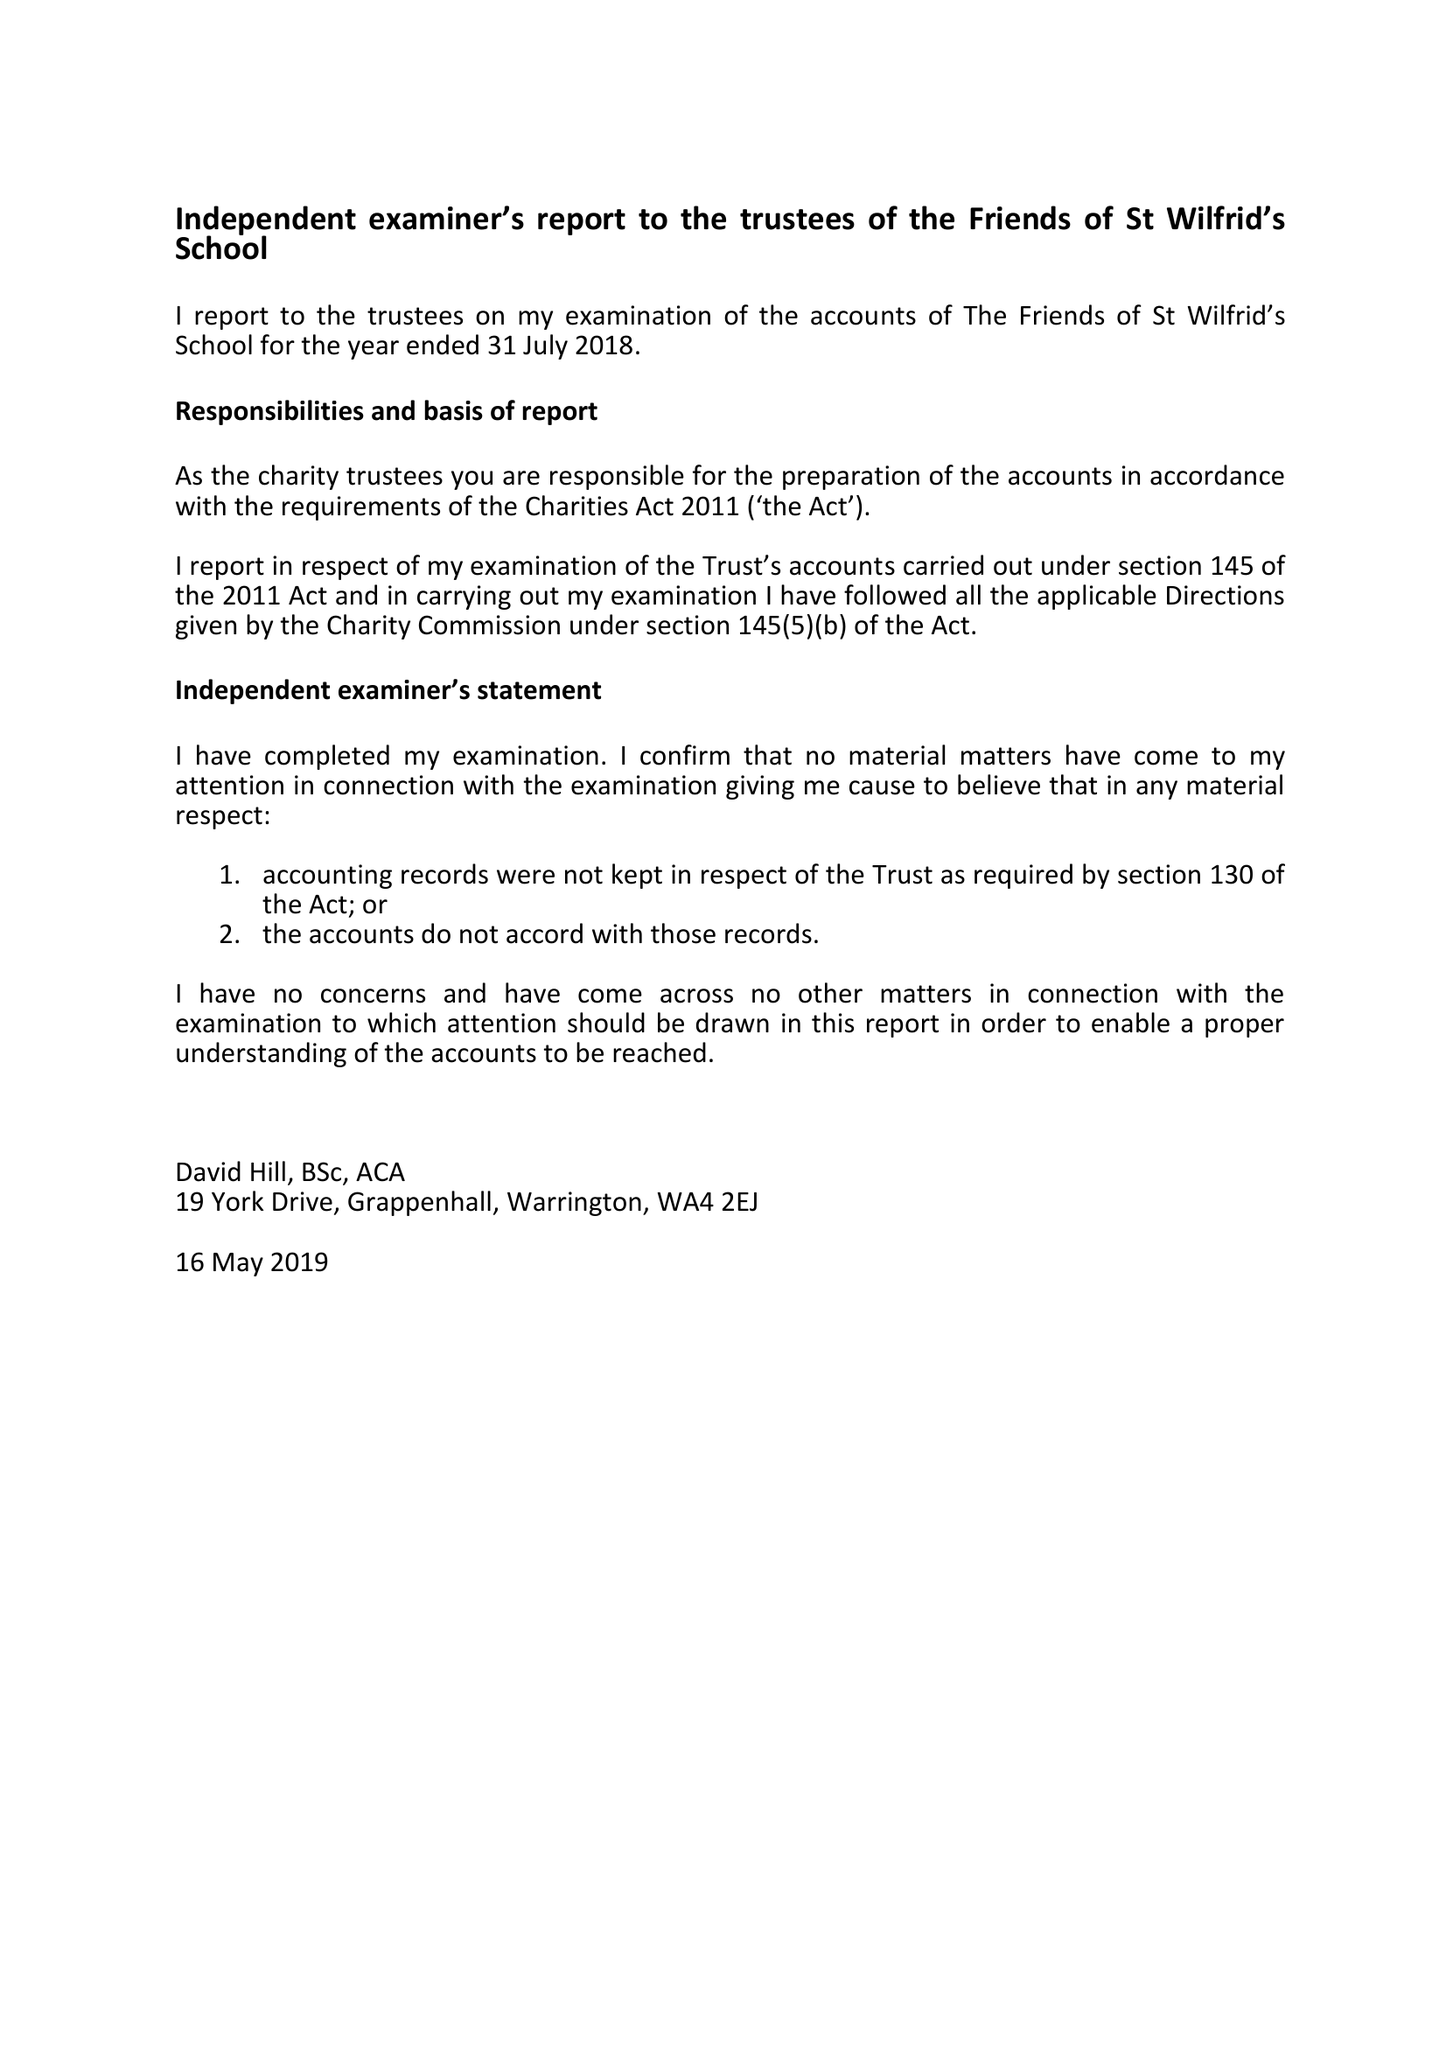What is the value for the address__postcode?
Answer the question using a single word or phrase. WA4 2LU 